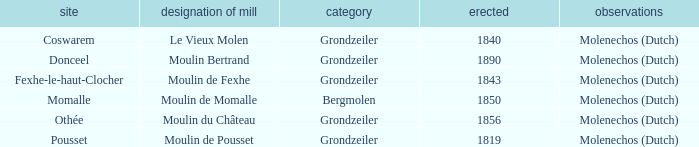What is the Location of the Moulin Bertrand Mill? Donceel. 